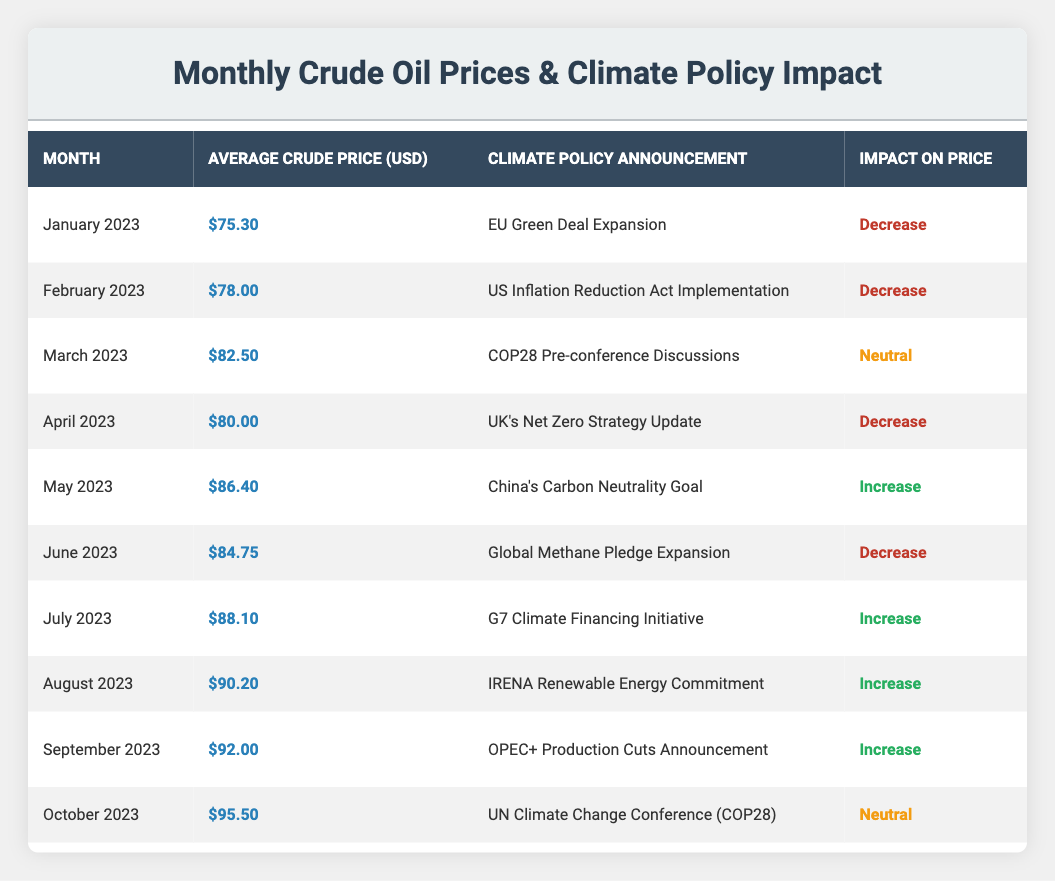What was the average crude oil price in June 2023? The average crude oil price for June 2023 is listed directly in the table as $84.75.
Answer: $84.75 Which month had the highest average crude oil price? By scanning the table, October 2023 has the highest average crude oil price at $95.50.
Answer: October 2023 How many months saw a decrease in crude oil prices due to climate policy announcements? Counting the months with a "Decrease" impact, there are five instances: January, February, April, June, and October.
Answer: 5 What was the impact on crude oil prices in May 2023? The table indicates that the climate policy announcement in May 2023 resulted in an "Increase" in crude oil prices.
Answer: Increase What is the difference in average crude oil prices between September 2023 and March 2023? The price for September 2023 is $92.00 and for March 2023 is $82.50. The difference is $92.00 - $82.50 = $9.50.
Answer: $9.50 Did the average crude oil price ever increase after a climate policy announcement in the months leading up to October 2023? Yes, the months of May, July, August, and September all showed an increase after their respective climate policy announcements.
Answer: Yes Which climate policy announcement in 2023 was associated with the lowest crude oil price, and what was that price? The lowest crude oil price listed is $75.30 in January 2023, associated with the "EU Green Deal Expansion."
Answer: $75.30, EU Green Deal Expansion What can be inferred about the relationship between climate policy announcements and crude oil prices from May to September 2023? From May to September, all climate policy announcements led to increases in crude oil prices, indicating a potential correlation where positive sentiment or actions regarding climate may temporarily bolster prices.
Answer: Increases in prices indicate a potential correlation How does the average crude price of August 2023 compare to the price in June 2023? The average crude price in August 2023 is $90.20, while the price in June 2023 is $84.75. The difference shows an increase of $5.45.
Answer: Increase of $5.45 Was there a climate policy announcement in March 2023 that had a neutral impact on crude oil prices? Yes, the climate policy announcement during March 2023 (COP28 Pre-conference Discussions) had a neutral impact according to the table.
Answer: Yes 